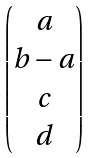Convert formula to latex. <formula><loc_0><loc_0><loc_500><loc_500>\begin{pmatrix} a \\ b - a \\ c \\ d \end{pmatrix}</formula> 